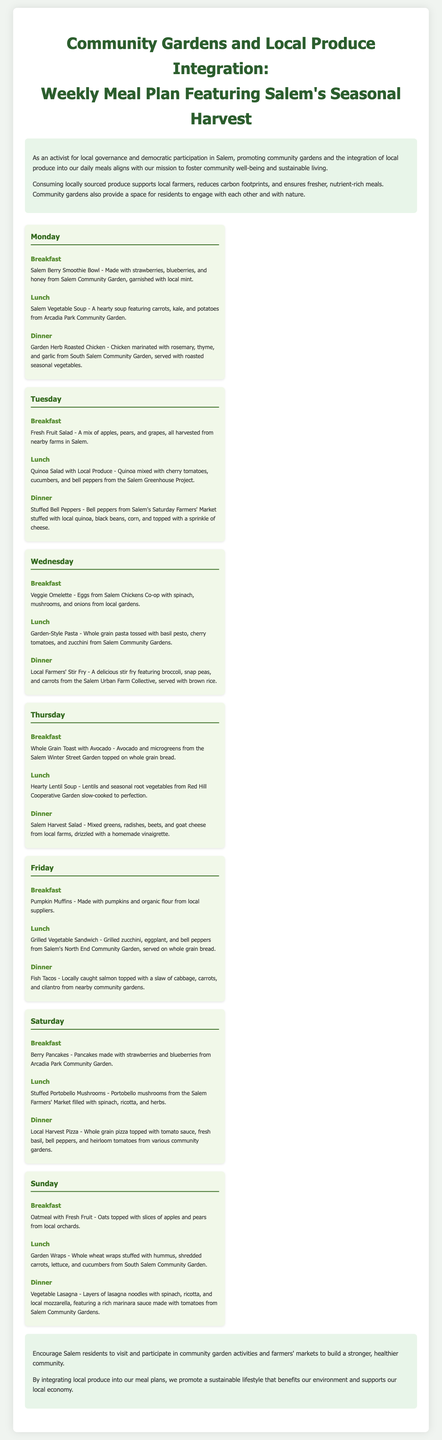What is the meal featured for breakfast on Monday? The meal plan lists "Salem Berry Smoothie Bowl" as the breakfast for Monday.
Answer: Salem Berry Smoothie Bowl Which community garden contributes to the lunch on Wednesday? The lunch on Wednesday, "Local Farmers' Stir Fry," features produce from the Salem Urban Farm Collective.
Answer: Salem Urban Farm Collective What is the focus of the meal plan? The meal plan focuses on the integration of local produce and community gardens in Salem's seasonal harvest.
Answer: Local produce integration How many meals are suggested for each day in the meal plan? Each day in the meal plan suggests three meals: breakfast, lunch, and dinner.
Answer: Three meals What type of soup is recommended for Thursday's lunch? The meal plan recommends "Hearty Lentil Soup" for Thursday's lunch.
Answer: Hearty Lentil Soup Which day features "Fish Tacos" for dinner? "Fish Tacos" are listed for dinner on Friday.
Answer: Friday What vegetable is used in the breakfast on Thursday? The breakfast on Thursday includes avocado.
Answer: Avocado How many days include a salad as part of the meals? The meal plan features a salad on both Thursday and Friday, totaling two days with salads.
Answer: Two days 